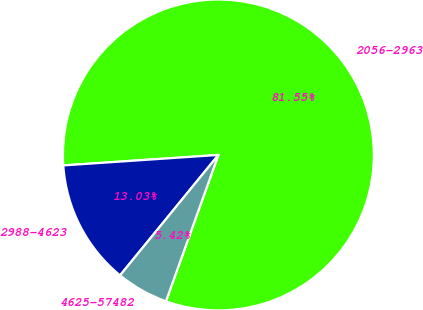Convert chart. <chart><loc_0><loc_0><loc_500><loc_500><pie_chart><fcel>2056-2963<fcel>2988-4623<fcel>4625-57482<nl><fcel>81.55%<fcel>13.03%<fcel>5.42%<nl></chart> 